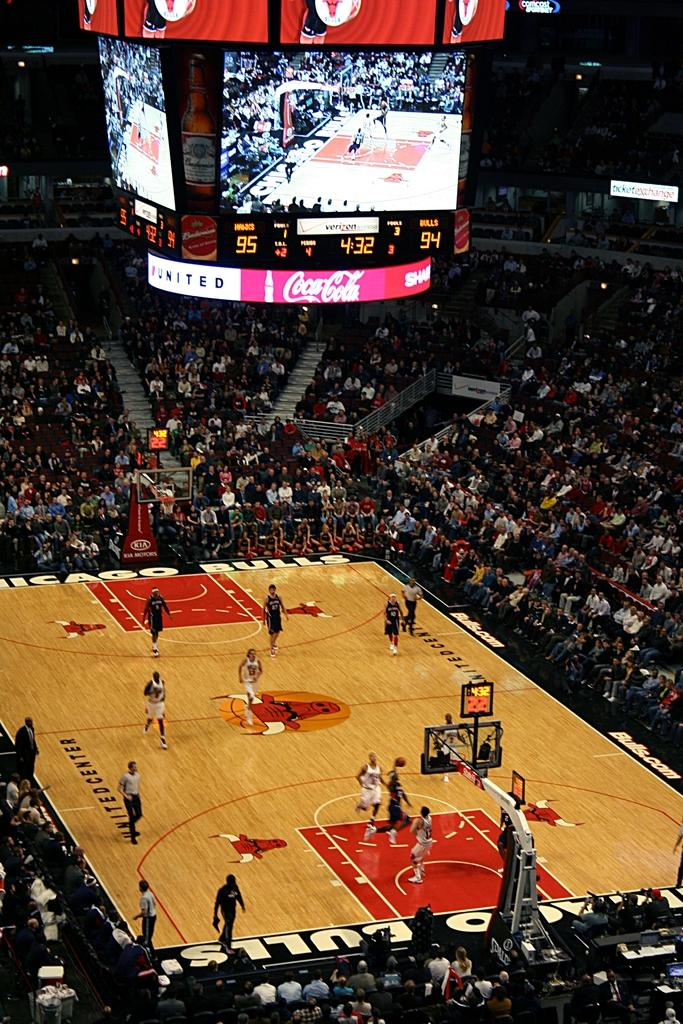<image>
Share a concise interpretation of the image provided. a long range view of a chicago bulls basket ball game. 